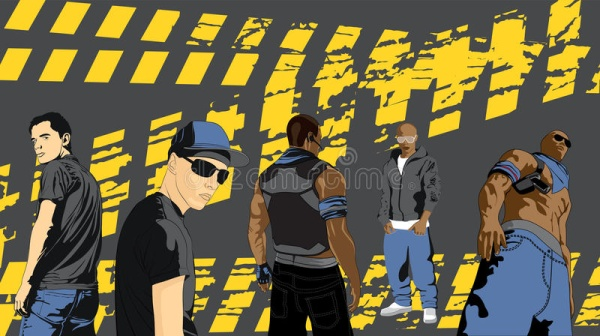Can you write a short story based on the characters in the image? Once upon a time in a vibrant city, five friends known for their unique styles and strong bonds gathered on a quiet street. Jason, the confident leader with crossed arms, was planning a daring adventure. Tony, with his baseball cap and sunglasses, was always ready to face any challenge head-on. Max, the mysterious one who often kept his back turned, had a knack for solving puzzles. Chris, with his laid-back demeanor, was the group's calm amidst any storm. Lastly, there was Luke, who took pride in his physical strength and was always eager to prove himself. Together, they formed an unstoppable team, ready to face any adventure that came their way, each playing their crucial role in overcoming obstacles and discovering new horizons. What was the most challenging adventure they embarked on? Their most challenging adventure was the search for the legendary city of Zalon hidden deep within a foreboding forest. They navigated through treacherous terrain, solved ancient riddles, and faced unknown dangers. Jason's leadership and strategy guided them safely, while Tony's bravery led them through the darkest paths. Max's intellect unravelled the enigmatic riddles that barred their way. Chris's calm nature helped them stay focused and united during the moments of panic. Luke's strength was critical in overcoming physical barriers. Together, they unearthed the secrets of Zalon and discovered treasures and knowledge that bonded their friendship even more tightly. What did they discover in the legendary city of Zalon? In Zalon, they discovered a hidden trove of ancient artifacts and knowledge, including scrolls that revealed forgotten technologies and secrets that could alter their world forever. They also found a mystical crystal rumored to possess incredible powers, capable of healing and prosperity. The city's inhabitants, descendants of an ancient civilization, welcomed them and shared their wisdom. Their journey through Zalon not only enriched their minds but also strengthened the bonds of their friendship, ensuring that their legend would be told for generations. 